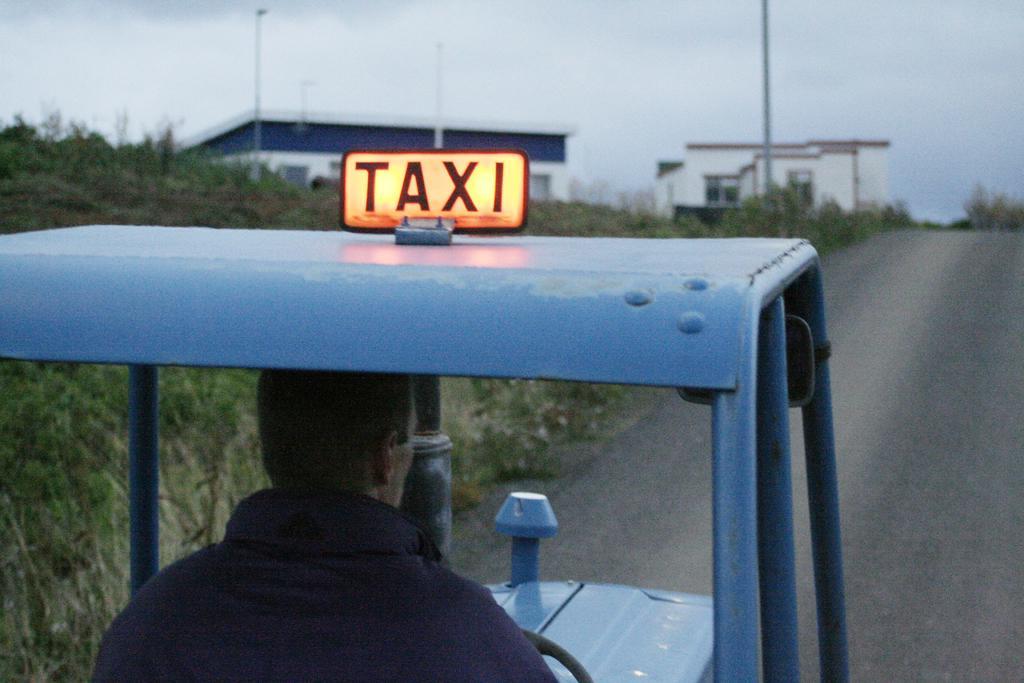Describe this image in one or two sentences. In this image we can see a person is riding vehicle on the road. In the background we can see grass on the ground, poles, buildings, windows and clouds in the sky. 